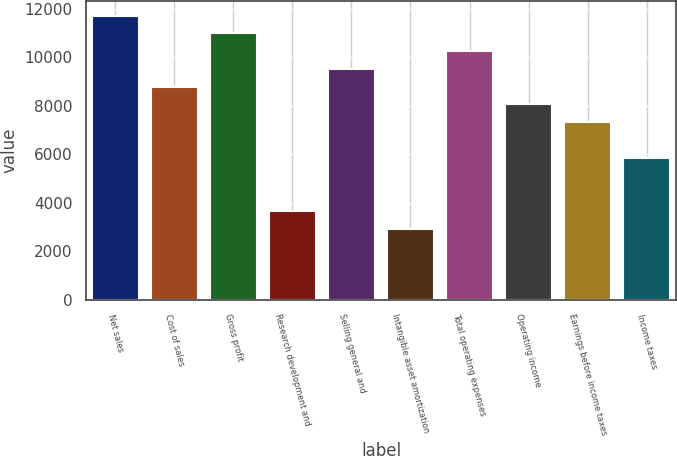<chart> <loc_0><loc_0><loc_500><loc_500><bar_chart><fcel>Net sales<fcel>Cost of sales<fcel>Gross profit<fcel>Research development and<fcel>Selling general and<fcel>Intangible asset amortization<fcel>Total operating expenses<fcel>Operating income<fcel>Earnings before income taxes<fcel>Income taxes<nl><fcel>11710.1<fcel>8783.38<fcel>10978.5<fcel>3661.55<fcel>9515.07<fcel>2929.86<fcel>10246.8<fcel>8051.69<fcel>7320<fcel>5856.62<nl></chart> 